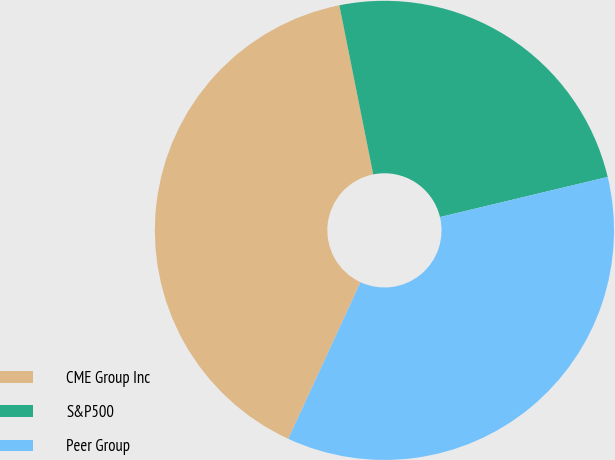Convert chart. <chart><loc_0><loc_0><loc_500><loc_500><pie_chart><fcel>CME Group Inc<fcel>S&P500<fcel>Peer Group<nl><fcel>39.98%<fcel>24.41%<fcel>35.62%<nl></chart> 